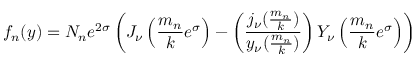Convert formula to latex. <formula><loc_0><loc_0><loc_500><loc_500>f _ { n } ( y ) = N _ { n } e ^ { 2 \sigma } \left ( J _ { \nu } \left ( { \frac { m _ { n } } { k } } e ^ { \sigma } \right ) - \left ( { \frac { j _ { \nu } ( { \frac { m _ { n } } { k } } ) } { y _ { \nu } ( { \frac { m _ { n } } { k } } ) } } \right ) Y _ { \nu } \left ( { \frac { m _ { n } } { k } } e ^ { \sigma } \right ) \right )</formula> 